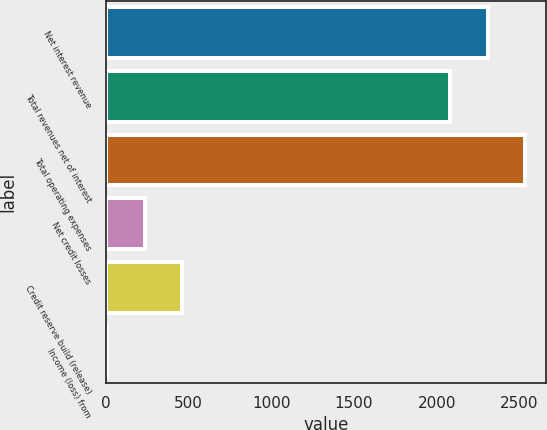Convert chart to OTSL. <chart><loc_0><loc_0><loc_500><loc_500><bar_chart><fcel>Net interest revenue<fcel>Total revenues net of interest<fcel>Total operating expenses<fcel>Net credit losses<fcel>Credit reserve build (release)<fcel>Income (loss) from<nl><fcel>2309.4<fcel>2083<fcel>2535.8<fcel>234.4<fcel>460.8<fcel>8<nl></chart> 